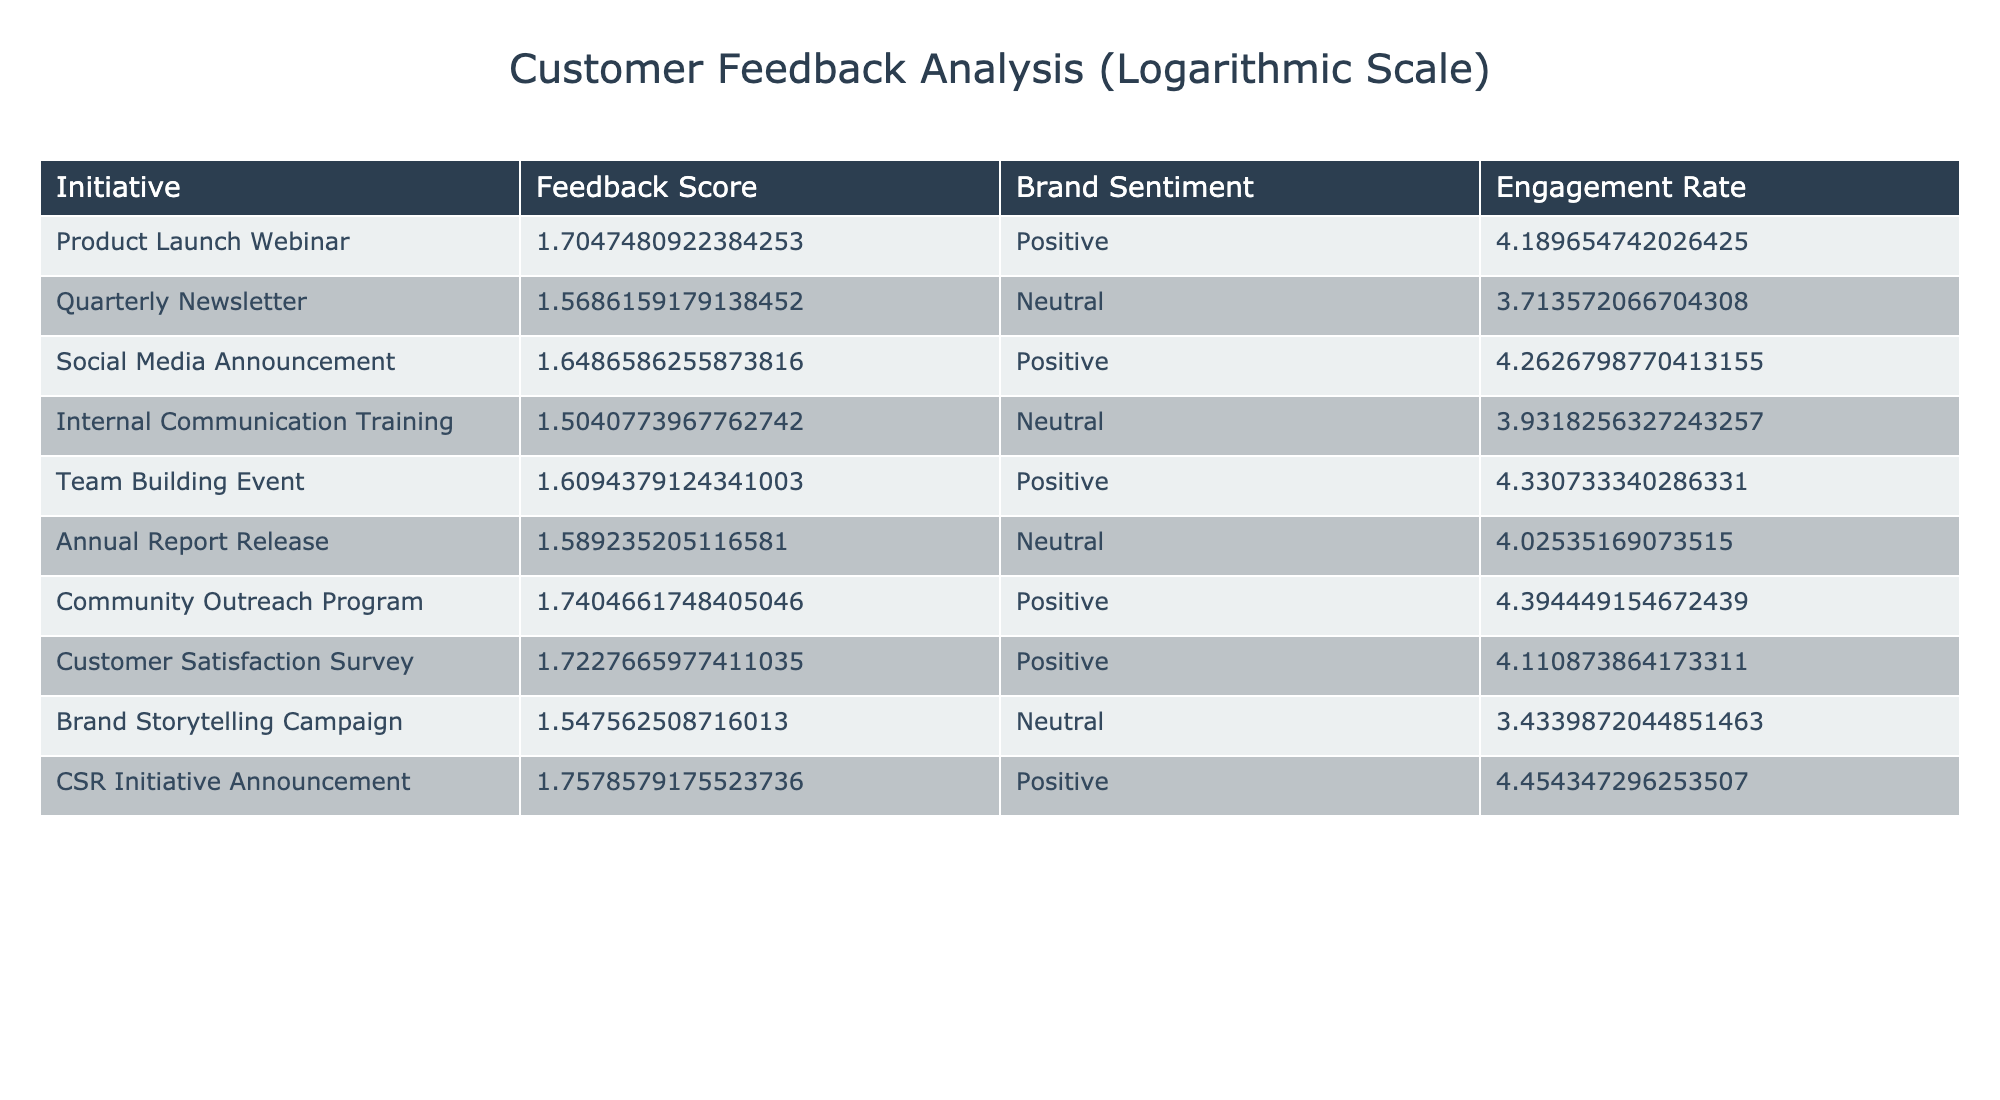What is the Feedback Score for the Community Outreach Program? The Feedback Score for the Community Outreach Program is listed directly in the table under the respective initiative. It is 4.7.
Answer: 4.7 What is the Engagement Rate for the CSR Initiative Announcement? The Engagement Rate for the CSR Initiative Announcement can be found in the table where the initiative is mentioned. It shows a score of 85.
Answer: 85 Which initiative has the highest Brand Sentiment? The initiative with the highest Brand Sentiment is the CSR Initiative Announcement, which is marked as Positive, and its Feedback Score is 4.8.
Answer: CSR Initiative Announcement What is the average Engagement Rate for all initiatives that received a Neutral Brand Sentiment? The Engagement Rates for initiatives with Neutral Brand Sentiment are 40, 50, 55, and 30. Adding these gives 40 + 50 + 55 + 30 = 175. There are 4 such initiatives, so the average is 175 / 4 = 43.75.
Answer: 43.75 Did the Team Building Event receive a higher or lower Feedback Score than the Annual Report Release? The Feedback Score for the Team Building Event is 4.0, while for the Annual Report Release, it is 3.9. Since 4.0 > 3.9, the Team Building Event had a higher Feedback Score.
Answer: Higher What is the total Feedback Score for all initiatives that are marked as Positive? The Feedback Scores for Positive initiatives are 4.5, 4.2, 4.0, 4.7, 4.6, 4.8. Adding these scores gives a total of 4.5 + 4.2 + 4.0 + 4.7 + 4.6 + 4.8 = 26.8.
Answer: 26.8 Is the Engagement Rate for the Product Launch Webinar greater than or equal to the average Engagement Rate of all initiatives? The Engagement Rate for the Product Launch Webinar is 65. The average Engagement Rate across all initiatives can be calculated by summing all Engagement Rates (65 + 40 + 70 + 50 + 75 + 55 + 80 + 60 + 30 + 85 = 690) and dividing by the number of initiatives (10), which gives an average of 69. Therefore, 65 is less than the average Engagement Rate.
Answer: No Which two initiatives have the closest Feedback Scores and what are their scores? By examining the scores in the table, the two initiatives closest in Feedback Score are the Annual Report Release (3.9) and the Quarterly Newsletter (3.8), with a difference of 0.1.
Answer: 3.9 and 3.8 